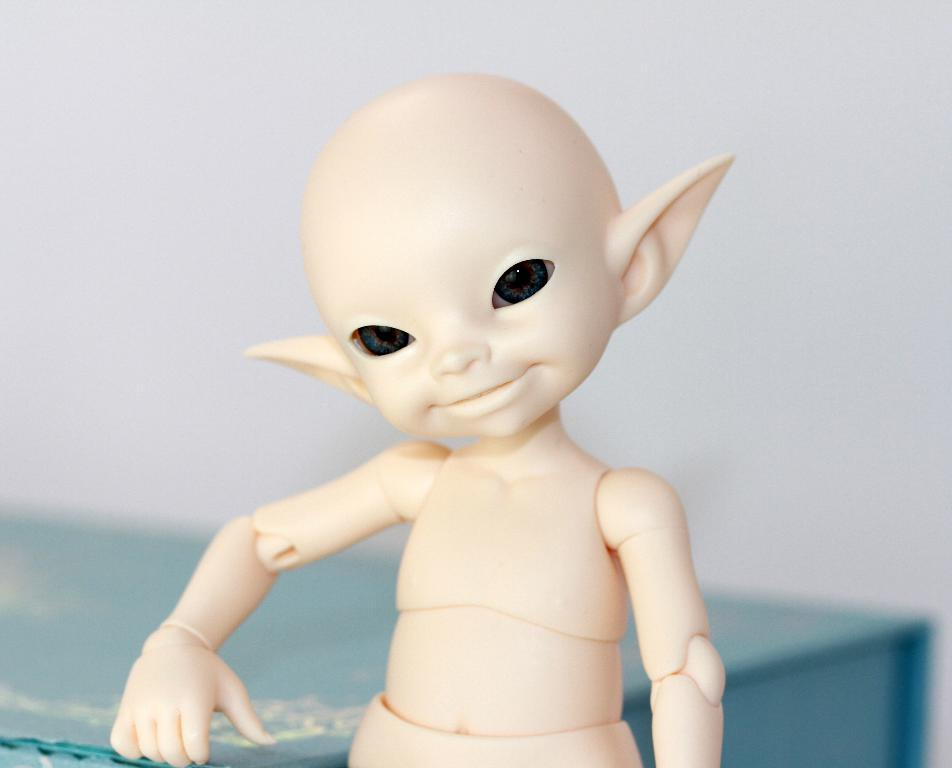What object can be seen in the image? There is a toy in the image. What color is the toy? The toy is cream-colored. What type of furniture is present in the image? There is a blue desk in the image. What can be seen in the background of the image? There is a wall in the background of the image. How many spiders are sitting on the toy in the image? There are no spiders present in the image; it only features a toy and a blue desk. What type of throne is visible in the image? There is no throne present in the image; it only features a toy and a blue desk. 